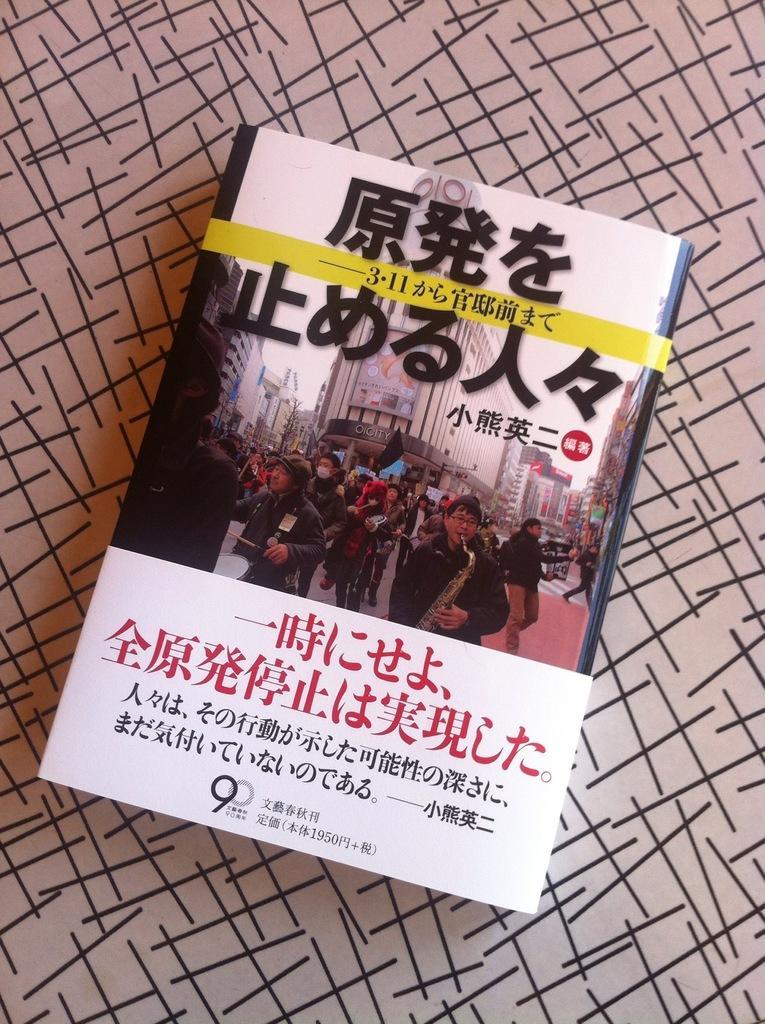Please provide a concise description of this image. In this picture we can see a foreign language book kept on a table. 